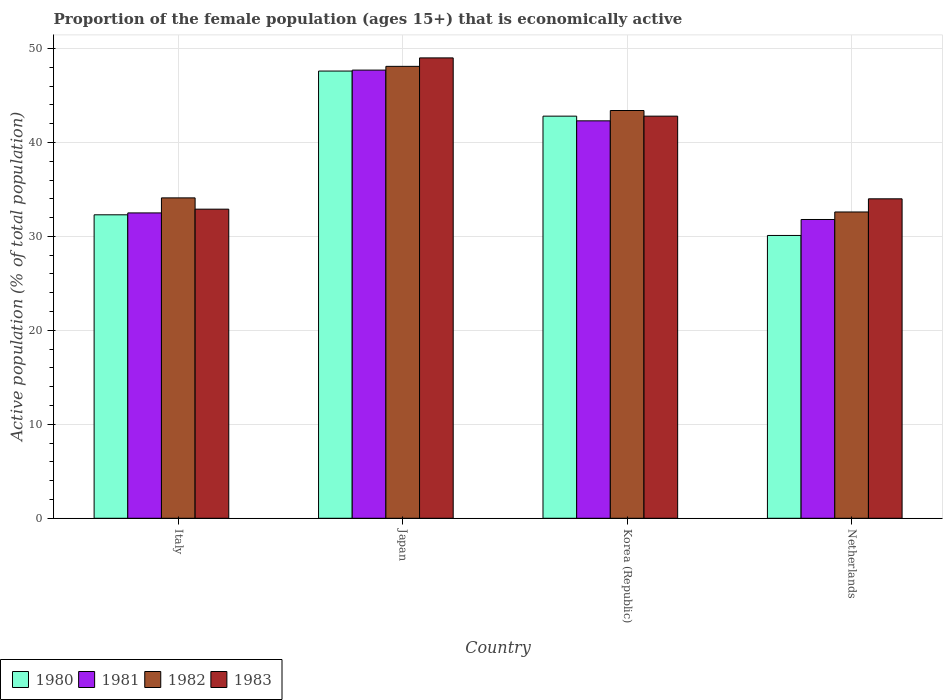How many groups of bars are there?
Your answer should be compact. 4. Are the number of bars on each tick of the X-axis equal?
Ensure brevity in your answer.  Yes. How many bars are there on the 3rd tick from the left?
Provide a succinct answer. 4. How many bars are there on the 3rd tick from the right?
Make the answer very short. 4. In how many cases, is the number of bars for a given country not equal to the number of legend labels?
Ensure brevity in your answer.  0. What is the proportion of the female population that is economically active in 1981 in Japan?
Provide a short and direct response. 47.7. Across all countries, what is the maximum proportion of the female population that is economically active in 1981?
Your answer should be compact. 47.7. Across all countries, what is the minimum proportion of the female population that is economically active in 1982?
Your answer should be compact. 32.6. In which country was the proportion of the female population that is economically active in 1981 minimum?
Offer a terse response. Netherlands. What is the total proportion of the female population that is economically active in 1981 in the graph?
Your answer should be compact. 154.3. What is the difference between the proportion of the female population that is economically active in 1980 in Italy and that in Netherlands?
Offer a very short reply. 2.2. What is the average proportion of the female population that is economically active in 1980 per country?
Offer a terse response. 38.2. What is the difference between the proportion of the female population that is economically active of/in 1982 and proportion of the female population that is economically active of/in 1983 in Korea (Republic)?
Offer a terse response. 0.6. What is the ratio of the proportion of the female population that is economically active in 1980 in Italy to that in Korea (Republic)?
Provide a succinct answer. 0.75. Is the proportion of the female population that is economically active in 1980 in Italy less than that in Korea (Republic)?
Your answer should be very brief. Yes. What is the difference between the highest and the second highest proportion of the female population that is economically active in 1981?
Ensure brevity in your answer.  -9.8. What is the difference between the highest and the lowest proportion of the female population that is economically active in 1982?
Ensure brevity in your answer.  15.5. In how many countries, is the proportion of the female population that is economically active in 1982 greater than the average proportion of the female population that is economically active in 1982 taken over all countries?
Ensure brevity in your answer.  2. Is the sum of the proportion of the female population that is economically active in 1980 in Italy and Korea (Republic) greater than the maximum proportion of the female population that is economically active in 1982 across all countries?
Your answer should be compact. Yes. What does the 1st bar from the left in Korea (Republic) represents?
Your answer should be compact. 1980. What does the 3rd bar from the right in Italy represents?
Your answer should be compact. 1981. Is it the case that in every country, the sum of the proportion of the female population that is economically active in 1982 and proportion of the female population that is economically active in 1981 is greater than the proportion of the female population that is economically active in 1983?
Your response must be concise. Yes. What is the difference between two consecutive major ticks on the Y-axis?
Your answer should be compact. 10. Where does the legend appear in the graph?
Provide a short and direct response. Bottom left. How many legend labels are there?
Offer a very short reply. 4. What is the title of the graph?
Offer a very short reply. Proportion of the female population (ages 15+) that is economically active. Does "1962" appear as one of the legend labels in the graph?
Your answer should be compact. No. What is the label or title of the Y-axis?
Keep it short and to the point. Active population (% of total population). What is the Active population (% of total population) of 1980 in Italy?
Keep it short and to the point. 32.3. What is the Active population (% of total population) of 1981 in Italy?
Your response must be concise. 32.5. What is the Active population (% of total population) of 1982 in Italy?
Your response must be concise. 34.1. What is the Active population (% of total population) of 1983 in Italy?
Your answer should be compact. 32.9. What is the Active population (% of total population) of 1980 in Japan?
Give a very brief answer. 47.6. What is the Active population (% of total population) of 1981 in Japan?
Your answer should be very brief. 47.7. What is the Active population (% of total population) of 1982 in Japan?
Your answer should be very brief. 48.1. What is the Active population (% of total population) in 1983 in Japan?
Offer a terse response. 49. What is the Active population (% of total population) in 1980 in Korea (Republic)?
Provide a short and direct response. 42.8. What is the Active population (% of total population) in 1981 in Korea (Republic)?
Make the answer very short. 42.3. What is the Active population (% of total population) of 1982 in Korea (Republic)?
Your answer should be very brief. 43.4. What is the Active population (% of total population) of 1983 in Korea (Republic)?
Keep it short and to the point. 42.8. What is the Active population (% of total population) in 1980 in Netherlands?
Make the answer very short. 30.1. What is the Active population (% of total population) of 1981 in Netherlands?
Provide a succinct answer. 31.8. What is the Active population (% of total population) in 1982 in Netherlands?
Make the answer very short. 32.6. Across all countries, what is the maximum Active population (% of total population) of 1980?
Offer a very short reply. 47.6. Across all countries, what is the maximum Active population (% of total population) in 1981?
Provide a succinct answer. 47.7. Across all countries, what is the maximum Active population (% of total population) of 1982?
Ensure brevity in your answer.  48.1. Across all countries, what is the minimum Active population (% of total population) of 1980?
Make the answer very short. 30.1. Across all countries, what is the minimum Active population (% of total population) of 1981?
Ensure brevity in your answer.  31.8. Across all countries, what is the minimum Active population (% of total population) of 1982?
Your answer should be very brief. 32.6. Across all countries, what is the minimum Active population (% of total population) of 1983?
Ensure brevity in your answer.  32.9. What is the total Active population (% of total population) of 1980 in the graph?
Ensure brevity in your answer.  152.8. What is the total Active population (% of total population) in 1981 in the graph?
Your answer should be very brief. 154.3. What is the total Active population (% of total population) in 1982 in the graph?
Your response must be concise. 158.2. What is the total Active population (% of total population) in 1983 in the graph?
Make the answer very short. 158.7. What is the difference between the Active population (% of total population) of 1980 in Italy and that in Japan?
Give a very brief answer. -15.3. What is the difference between the Active population (% of total population) in 1981 in Italy and that in Japan?
Offer a very short reply. -15.2. What is the difference between the Active population (% of total population) of 1982 in Italy and that in Japan?
Give a very brief answer. -14. What is the difference between the Active population (% of total population) in 1983 in Italy and that in Japan?
Give a very brief answer. -16.1. What is the difference between the Active population (% of total population) of 1981 in Italy and that in Korea (Republic)?
Offer a terse response. -9.8. What is the difference between the Active population (% of total population) in 1983 in Italy and that in Netherlands?
Ensure brevity in your answer.  -1.1. What is the difference between the Active population (% of total population) in 1981 in Japan and that in Korea (Republic)?
Offer a very short reply. 5.4. What is the difference between the Active population (% of total population) of 1982 in Japan and that in Korea (Republic)?
Ensure brevity in your answer.  4.7. What is the difference between the Active population (% of total population) of 1981 in Japan and that in Netherlands?
Keep it short and to the point. 15.9. What is the difference between the Active population (% of total population) in 1983 in Japan and that in Netherlands?
Give a very brief answer. 15. What is the difference between the Active population (% of total population) of 1981 in Korea (Republic) and that in Netherlands?
Your response must be concise. 10.5. What is the difference between the Active population (% of total population) in 1983 in Korea (Republic) and that in Netherlands?
Offer a terse response. 8.8. What is the difference between the Active population (% of total population) in 1980 in Italy and the Active population (% of total population) in 1981 in Japan?
Offer a very short reply. -15.4. What is the difference between the Active population (% of total population) of 1980 in Italy and the Active population (% of total population) of 1982 in Japan?
Give a very brief answer. -15.8. What is the difference between the Active population (% of total population) in 1980 in Italy and the Active population (% of total population) in 1983 in Japan?
Offer a terse response. -16.7. What is the difference between the Active population (% of total population) of 1981 in Italy and the Active population (% of total population) of 1982 in Japan?
Offer a very short reply. -15.6. What is the difference between the Active population (% of total population) in 1981 in Italy and the Active population (% of total population) in 1983 in Japan?
Your answer should be compact. -16.5. What is the difference between the Active population (% of total population) in 1982 in Italy and the Active population (% of total population) in 1983 in Japan?
Ensure brevity in your answer.  -14.9. What is the difference between the Active population (% of total population) of 1980 in Italy and the Active population (% of total population) of 1983 in Korea (Republic)?
Provide a short and direct response. -10.5. What is the difference between the Active population (% of total population) in 1981 in Italy and the Active population (% of total population) in 1983 in Korea (Republic)?
Provide a succinct answer. -10.3. What is the difference between the Active population (% of total population) of 1981 in Italy and the Active population (% of total population) of 1983 in Netherlands?
Make the answer very short. -1.5. What is the difference between the Active population (% of total population) in 1982 in Italy and the Active population (% of total population) in 1983 in Netherlands?
Provide a succinct answer. 0.1. What is the difference between the Active population (% of total population) in 1981 in Japan and the Active population (% of total population) in 1983 in Korea (Republic)?
Your answer should be compact. 4.9. What is the difference between the Active population (% of total population) of 1980 in Japan and the Active population (% of total population) of 1981 in Netherlands?
Your answer should be very brief. 15.8. What is the difference between the Active population (% of total population) in 1981 in Japan and the Active population (% of total population) in 1982 in Netherlands?
Provide a short and direct response. 15.1. What is the difference between the Active population (% of total population) in 1981 in Japan and the Active population (% of total population) in 1983 in Netherlands?
Provide a succinct answer. 13.7. What is the difference between the Active population (% of total population) of 1982 in Japan and the Active population (% of total population) of 1983 in Netherlands?
Make the answer very short. 14.1. What is the difference between the Active population (% of total population) in 1980 in Korea (Republic) and the Active population (% of total population) in 1982 in Netherlands?
Keep it short and to the point. 10.2. What is the difference between the Active population (% of total population) of 1980 in Korea (Republic) and the Active population (% of total population) of 1983 in Netherlands?
Your answer should be compact. 8.8. What is the difference between the Active population (% of total population) of 1981 in Korea (Republic) and the Active population (% of total population) of 1982 in Netherlands?
Offer a terse response. 9.7. What is the difference between the Active population (% of total population) in 1982 in Korea (Republic) and the Active population (% of total population) in 1983 in Netherlands?
Offer a very short reply. 9.4. What is the average Active population (% of total population) of 1980 per country?
Give a very brief answer. 38.2. What is the average Active population (% of total population) in 1981 per country?
Your answer should be compact. 38.58. What is the average Active population (% of total population) in 1982 per country?
Provide a succinct answer. 39.55. What is the average Active population (% of total population) of 1983 per country?
Provide a succinct answer. 39.67. What is the difference between the Active population (% of total population) of 1980 and Active population (% of total population) of 1981 in Italy?
Your response must be concise. -0.2. What is the difference between the Active population (% of total population) in 1980 and Active population (% of total population) in 1982 in Italy?
Offer a terse response. -1.8. What is the difference between the Active population (% of total population) in 1981 and Active population (% of total population) in 1983 in Italy?
Your answer should be compact. -0.4. What is the difference between the Active population (% of total population) of 1980 and Active population (% of total population) of 1982 in Japan?
Offer a terse response. -0.5. What is the difference between the Active population (% of total population) of 1981 and Active population (% of total population) of 1982 in Japan?
Give a very brief answer. -0.4. What is the difference between the Active population (% of total population) of 1981 and Active population (% of total population) of 1983 in Japan?
Keep it short and to the point. -1.3. What is the difference between the Active population (% of total population) of 1982 and Active population (% of total population) of 1983 in Japan?
Provide a succinct answer. -0.9. What is the difference between the Active population (% of total population) of 1980 and Active population (% of total population) of 1981 in Korea (Republic)?
Provide a short and direct response. 0.5. What is the difference between the Active population (% of total population) in 1980 and Active population (% of total population) in 1982 in Korea (Republic)?
Give a very brief answer. -0.6. What is the difference between the Active population (% of total population) of 1981 and Active population (% of total population) of 1983 in Korea (Republic)?
Your answer should be very brief. -0.5. What is the difference between the Active population (% of total population) in 1982 and Active population (% of total population) in 1983 in Korea (Republic)?
Give a very brief answer. 0.6. What is the difference between the Active population (% of total population) of 1980 and Active population (% of total population) of 1981 in Netherlands?
Your answer should be very brief. -1.7. What is the difference between the Active population (% of total population) in 1980 and Active population (% of total population) in 1982 in Netherlands?
Provide a short and direct response. -2.5. What is the difference between the Active population (% of total population) of 1980 and Active population (% of total population) of 1983 in Netherlands?
Ensure brevity in your answer.  -3.9. What is the difference between the Active population (% of total population) in 1981 and Active population (% of total population) in 1982 in Netherlands?
Give a very brief answer. -0.8. What is the difference between the Active population (% of total population) in 1982 and Active population (% of total population) in 1983 in Netherlands?
Ensure brevity in your answer.  -1.4. What is the ratio of the Active population (% of total population) in 1980 in Italy to that in Japan?
Your answer should be very brief. 0.68. What is the ratio of the Active population (% of total population) in 1981 in Italy to that in Japan?
Your response must be concise. 0.68. What is the ratio of the Active population (% of total population) of 1982 in Italy to that in Japan?
Your answer should be very brief. 0.71. What is the ratio of the Active population (% of total population) of 1983 in Italy to that in Japan?
Your answer should be compact. 0.67. What is the ratio of the Active population (% of total population) in 1980 in Italy to that in Korea (Republic)?
Your answer should be very brief. 0.75. What is the ratio of the Active population (% of total population) in 1981 in Italy to that in Korea (Republic)?
Make the answer very short. 0.77. What is the ratio of the Active population (% of total population) in 1982 in Italy to that in Korea (Republic)?
Your answer should be compact. 0.79. What is the ratio of the Active population (% of total population) in 1983 in Italy to that in Korea (Republic)?
Provide a succinct answer. 0.77. What is the ratio of the Active population (% of total population) in 1980 in Italy to that in Netherlands?
Offer a very short reply. 1.07. What is the ratio of the Active population (% of total population) in 1981 in Italy to that in Netherlands?
Offer a very short reply. 1.02. What is the ratio of the Active population (% of total population) in 1982 in Italy to that in Netherlands?
Offer a very short reply. 1.05. What is the ratio of the Active population (% of total population) of 1983 in Italy to that in Netherlands?
Make the answer very short. 0.97. What is the ratio of the Active population (% of total population) of 1980 in Japan to that in Korea (Republic)?
Keep it short and to the point. 1.11. What is the ratio of the Active population (% of total population) in 1981 in Japan to that in Korea (Republic)?
Provide a short and direct response. 1.13. What is the ratio of the Active population (% of total population) in 1982 in Japan to that in Korea (Republic)?
Make the answer very short. 1.11. What is the ratio of the Active population (% of total population) of 1983 in Japan to that in Korea (Republic)?
Provide a short and direct response. 1.14. What is the ratio of the Active population (% of total population) in 1980 in Japan to that in Netherlands?
Provide a short and direct response. 1.58. What is the ratio of the Active population (% of total population) of 1981 in Japan to that in Netherlands?
Provide a succinct answer. 1.5. What is the ratio of the Active population (% of total population) of 1982 in Japan to that in Netherlands?
Ensure brevity in your answer.  1.48. What is the ratio of the Active population (% of total population) in 1983 in Japan to that in Netherlands?
Your answer should be compact. 1.44. What is the ratio of the Active population (% of total population) of 1980 in Korea (Republic) to that in Netherlands?
Offer a terse response. 1.42. What is the ratio of the Active population (% of total population) of 1981 in Korea (Republic) to that in Netherlands?
Ensure brevity in your answer.  1.33. What is the ratio of the Active population (% of total population) in 1982 in Korea (Republic) to that in Netherlands?
Give a very brief answer. 1.33. What is the ratio of the Active population (% of total population) of 1983 in Korea (Republic) to that in Netherlands?
Offer a very short reply. 1.26. What is the difference between the highest and the second highest Active population (% of total population) in 1980?
Ensure brevity in your answer.  4.8. What is the difference between the highest and the second highest Active population (% of total population) in 1981?
Offer a very short reply. 5.4. What is the difference between the highest and the lowest Active population (% of total population) of 1981?
Your response must be concise. 15.9. What is the difference between the highest and the lowest Active population (% of total population) of 1982?
Your response must be concise. 15.5. What is the difference between the highest and the lowest Active population (% of total population) of 1983?
Offer a very short reply. 16.1. 